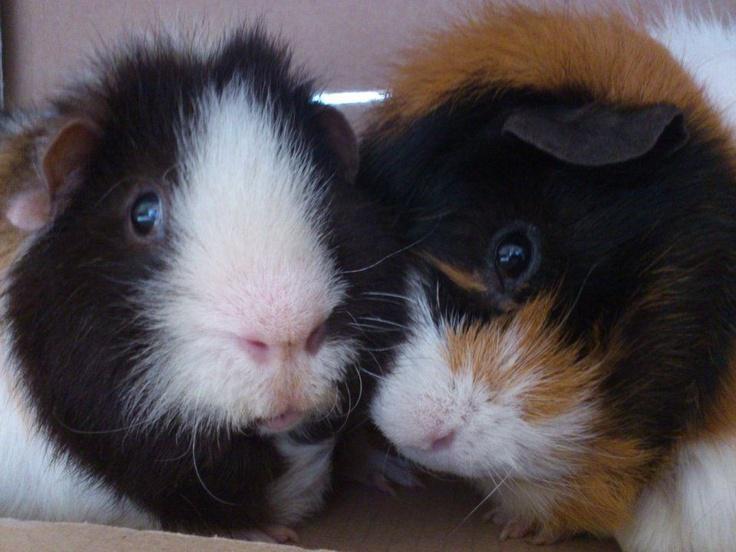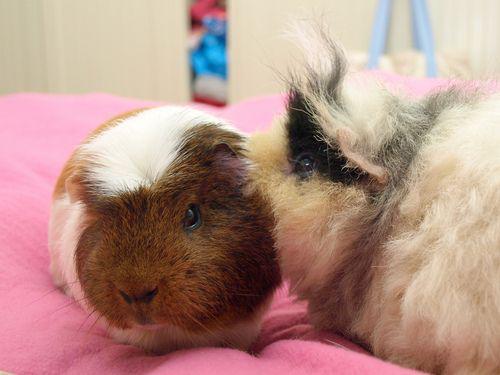The first image is the image on the left, the second image is the image on the right. For the images shown, is this caption "One image shows a single multicolor pet rodent held in a human hand." true? Answer yes or no. No. The first image is the image on the left, the second image is the image on the right. For the images displayed, is the sentence "The right image contains exactly two guinea pigs." factually correct? Answer yes or no. Yes. 